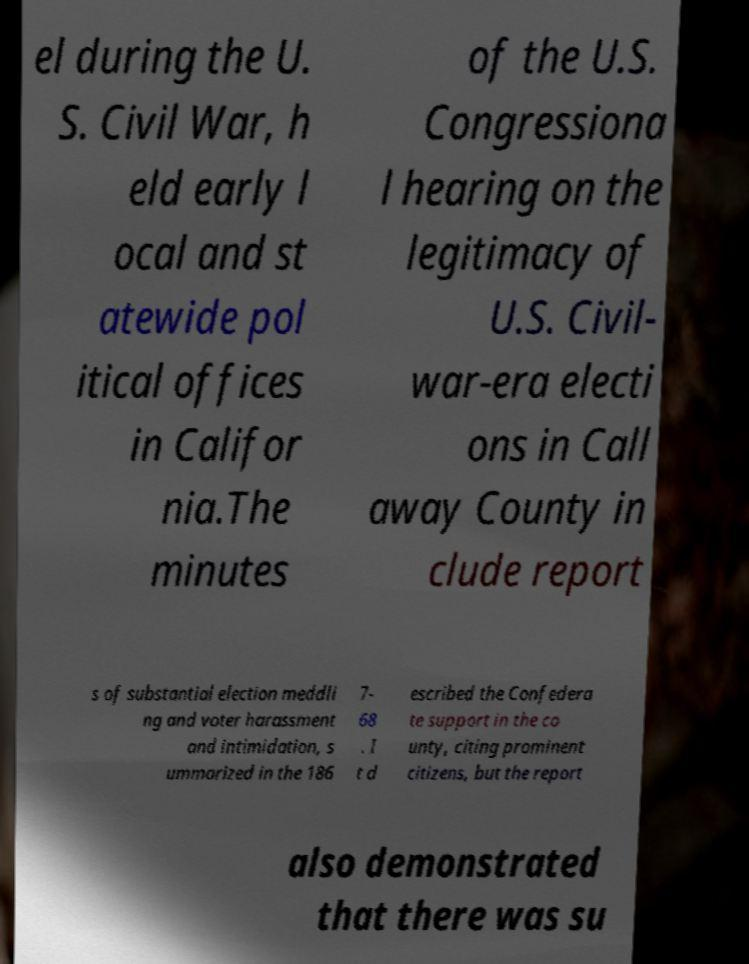What messages or text are displayed in this image? I need them in a readable, typed format. el during the U. S. Civil War, h eld early l ocal and st atewide pol itical offices in Califor nia.The minutes of the U.S. Congressiona l hearing on the legitimacy of U.S. Civil- war-era electi ons in Call away County in clude report s of substantial election meddli ng and voter harassment and intimidation, s ummarized in the 186 7- 68 . I t d escribed the Confedera te support in the co unty, citing prominent citizens, but the report also demonstrated that there was su 